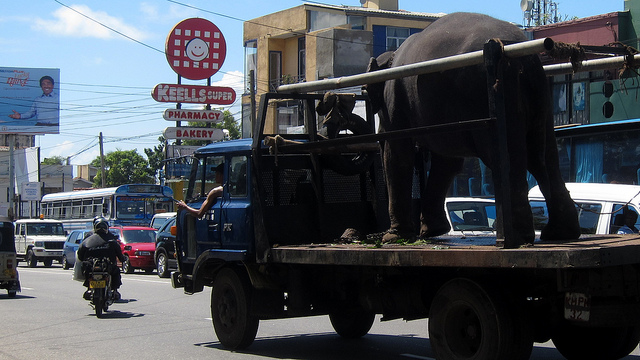<image>How did they get the elephant on the truck? It is unclear how they got the elephant on the truck. It could have been via a ramp, crane, or the elephant could have climbed. How did they get the elephant on the truck? I don't know how they got the elephant on the truck. It can be done using a ramp, crane, or lifting it. 